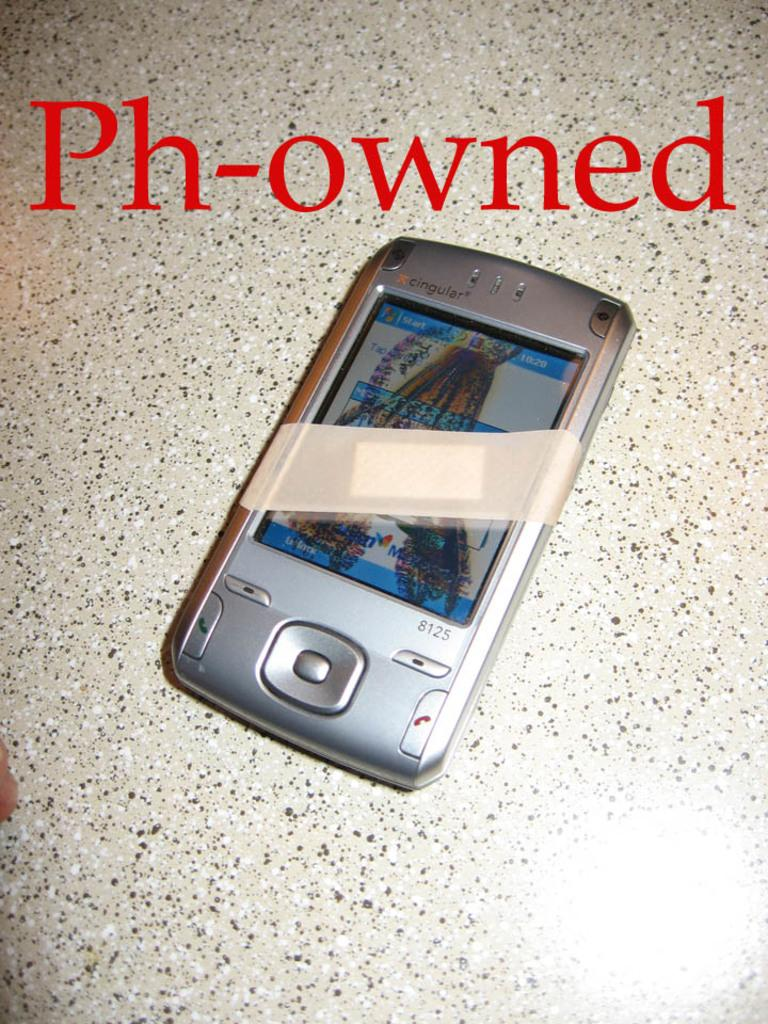Provide a one-sentence caption for the provided image. A phone with a bandage on it with letters on top saying Ph-owned. 